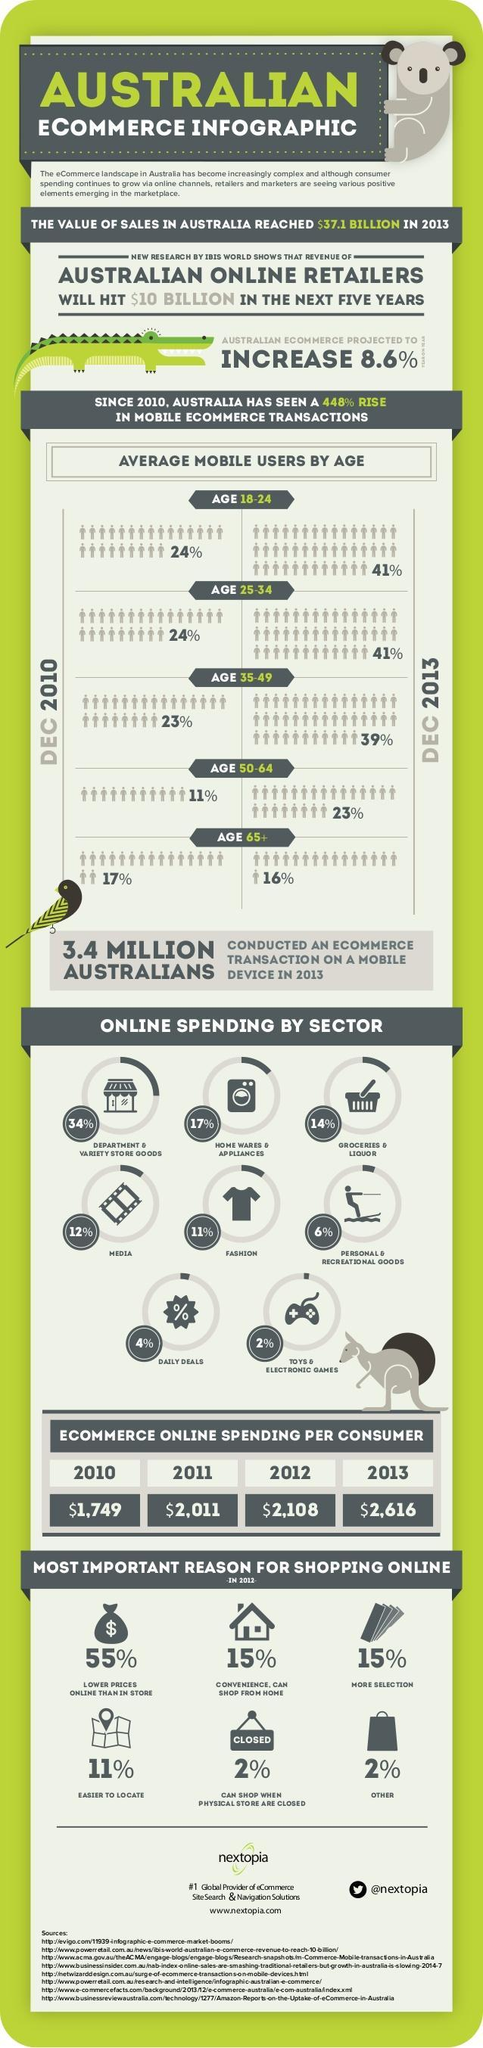What is the percentage of average mobile users in the age group of 65+ in Australia in Dec 2013?
Answer the question with a short phrase. 16% What percentage of online spending is done by personal & recreational goods in Australia? 6% What is the amount of ecommerce online spending per consumer in Australia in the year 2011? $2,011 What is the amount of ecommerce online spending per consumer in Australia in the year 2012? $2,108 What percentage of online spending is done by home wares & appliances in Australia? 17% What is the amount of ecommerce online spending per consumer in Australia in the year 2013? $2,616 What is the percentage of average mobile users in the age group of 35-49 in Australia in Dec 2013? 39% What is the percentage of average mobile users in the age group of 25-34 in Australia in Dec 2010? 24% 